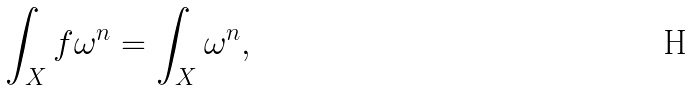Convert formula to latex. <formula><loc_0><loc_0><loc_500><loc_500>\int _ { X } f \omega ^ { n } = \int _ { X } \omega ^ { n } ,</formula> 